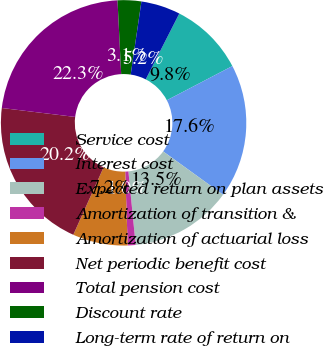Convert chart to OTSL. <chart><loc_0><loc_0><loc_500><loc_500><pie_chart><fcel>Service cost<fcel>Interest cost<fcel>Expected return on plan assets<fcel>Amortization of transition &<fcel>Amortization of actuarial loss<fcel>Net periodic benefit cost<fcel>Total pension cost<fcel>Discount rate<fcel>Long-term rate of return on<nl><fcel>9.84%<fcel>17.62%<fcel>13.47%<fcel>1.04%<fcel>7.25%<fcel>20.21%<fcel>22.28%<fcel>3.11%<fcel>5.18%<nl></chart> 